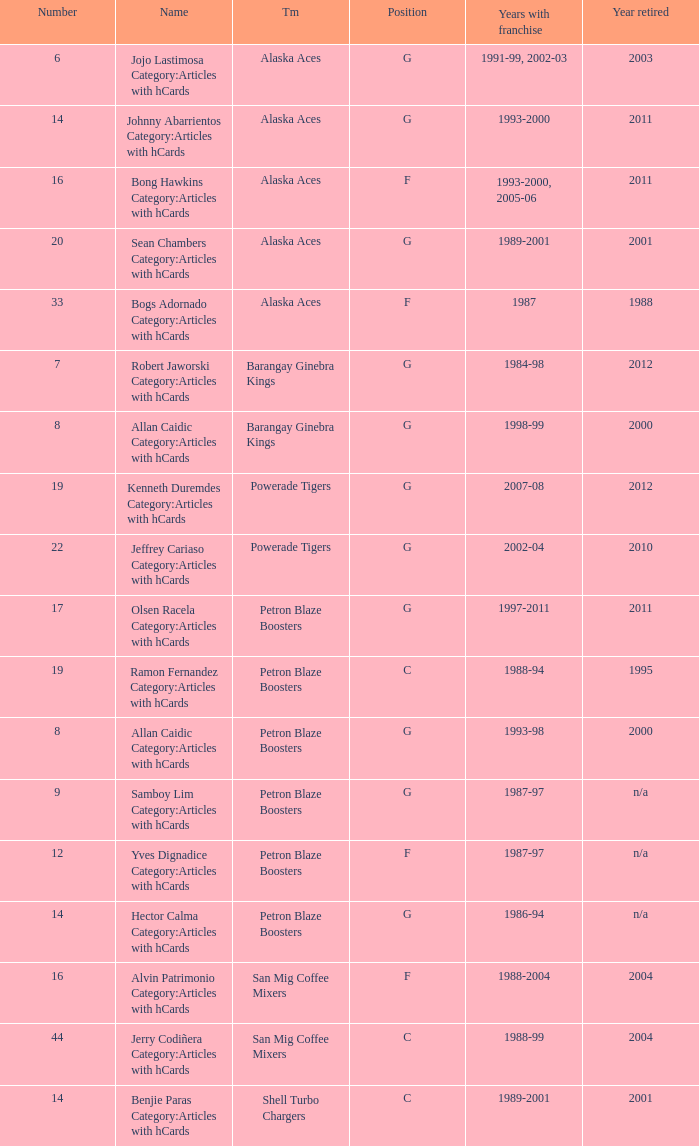How many years did the team in slot number 9 have a franchise? 1987-97. 